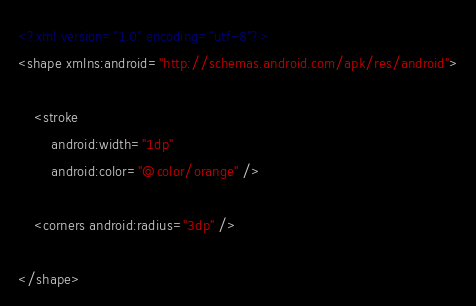<code> <loc_0><loc_0><loc_500><loc_500><_XML_><?xml version="1.0" encoding="utf-8"?>
<shape xmlns:android="http://schemas.android.com/apk/res/android">

    <stroke
        android:width="1dp"
        android:color="@color/orange" />

    <corners android:radius="3dp" />

</shape></code> 